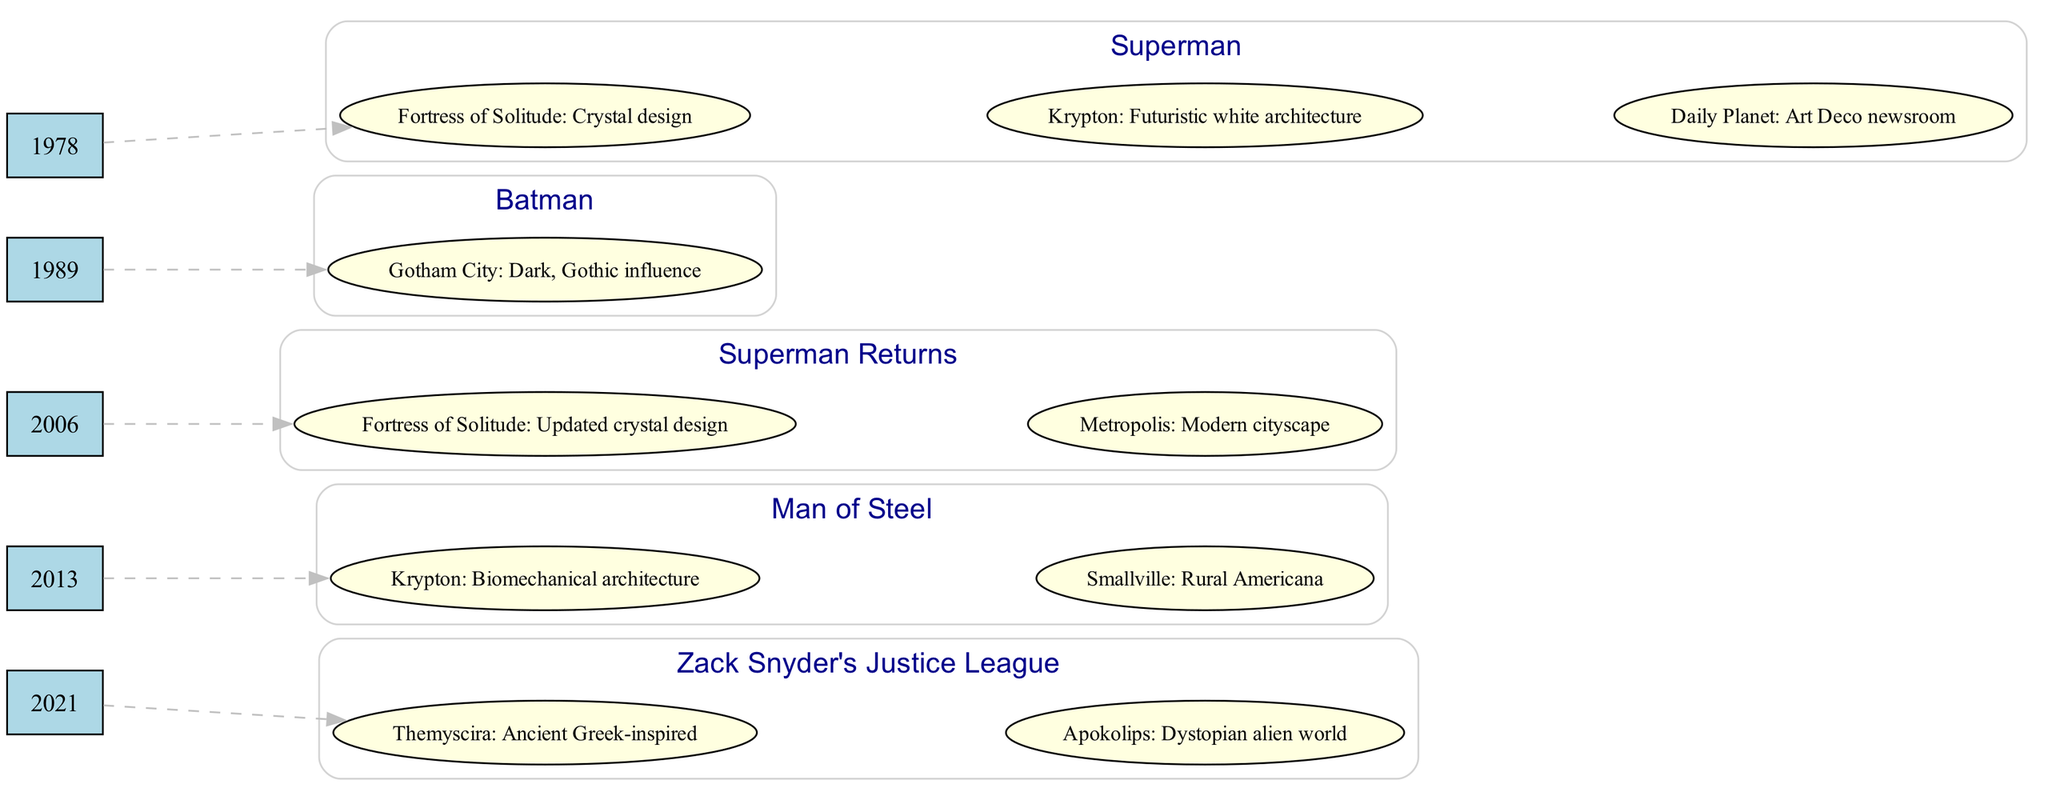What year was Superman Returns released? The diagram lists the film "Superman Returns" under the year 2006. Therefore, the answer is derived directly from the timeline information presented in the diagram.
Answer: 2006 What key visual element represents Krypton in Man of Steel? The diagram indicates that "Krypton" features "Biomechanical architecture" as a key visual element in the film "Man of Steel," which is one of the films highlighted in the timeline.
Answer: Biomechanical architecture How many key elements are listed for the film Superman in 1978? In the timeline, the film "Superman" from 1978 has three key elements listed: "Fortress of Solitude: Crystal design," "Krypton: Futuristic white architecture," and "Daily Planet: Art Deco newsroom." Therefore, by counting these elements, the answer is determined.
Answer: 3 Which film introduced a modern cityscape in its design? The diagram indicates that "Superman Returns" listed in 2006 introduced the "Metropolis: Modern cityscape" as one of its key elements. Thus, we derive the answer by identifying the associated visual element with its corresponding film in the timeline.
Answer: Superman Returns What is the primary theme of Themyscira in Zack Snyder's Justice League? According to the timeline, "Themyscira" is described as "Ancient Greek-inspired," which is a key element associated with the film "Zack Snyder's Justice League." This answer is found by examining the key elements related to that film in the diagram.
Answer: Ancient Greek-inspired Which year marks the beginning of the Superman film timeline? The timeline starts with the film "Superman" from the year 1978. Therefore, the answer is obtained by identifying the earliest year mentioned in the timeline data presented.
Answer: 1978 How does the architecture in Krypton evolve from 1978 to 2013? In the timeline, Krypton's design is initially described as "Futuristic white architecture" in 1978 (Superman) and then changes to "Biomechanical architecture" in 2013 (Man of Steel). By comparing these two descriptions across the years, we can determine the evolution of its architectural representation.
Answer: Changes to Biomechanical architecture What color is used for the timeline nodes? The diagram specifies that the timeline nodes are filled with "lightblue," which is indicated visually in the design details of the diagram for the nodes representing the years. Thus, the answer is found directly from the visual attributes assigned to those nodes.
Answer: Lightblue 